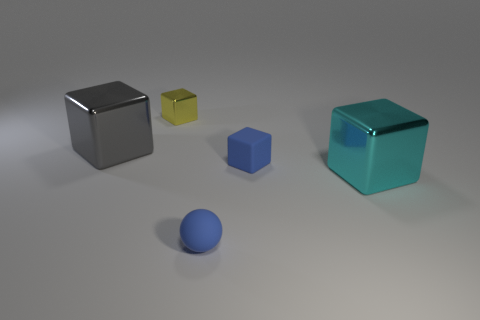Subtract 1 cubes. How many cubes are left? 3 Subtract all cyan cubes. How many cubes are left? 3 Add 4 gray cubes. How many objects exist? 9 Subtract all purple cubes. Subtract all purple cylinders. How many cubes are left? 4 Subtract all spheres. How many objects are left? 4 Add 1 small yellow metal things. How many small yellow metal things exist? 2 Subtract 0 purple cylinders. How many objects are left? 5 Subtract all yellow metallic cubes. Subtract all large objects. How many objects are left? 2 Add 5 yellow metal things. How many yellow metal things are left? 6 